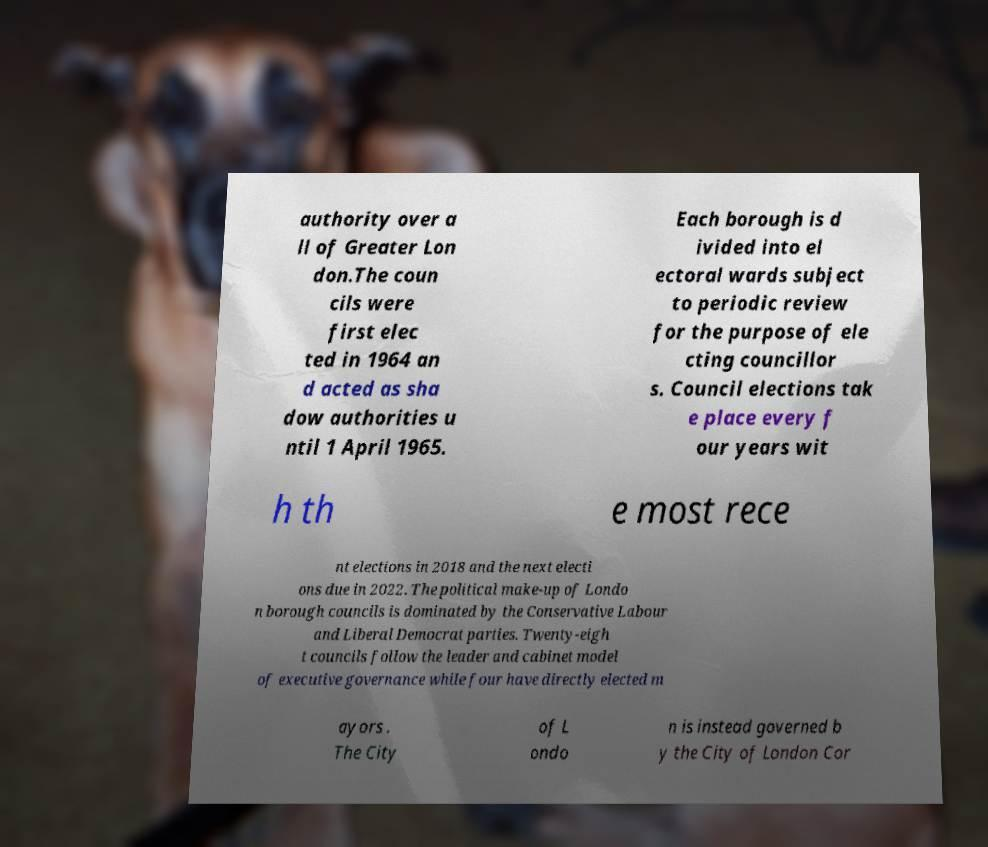Please read and relay the text visible in this image. What does it say? authority over a ll of Greater Lon don.The coun cils were first elec ted in 1964 an d acted as sha dow authorities u ntil 1 April 1965. Each borough is d ivided into el ectoral wards subject to periodic review for the purpose of ele cting councillor s. Council elections tak e place every f our years wit h th e most rece nt elections in 2018 and the next electi ons due in 2022. The political make-up of Londo n borough councils is dominated by the Conservative Labour and Liberal Democrat parties. Twenty-eigh t councils follow the leader and cabinet model of executive governance while four have directly elected m ayors . The City of L ondo n is instead governed b y the City of London Cor 